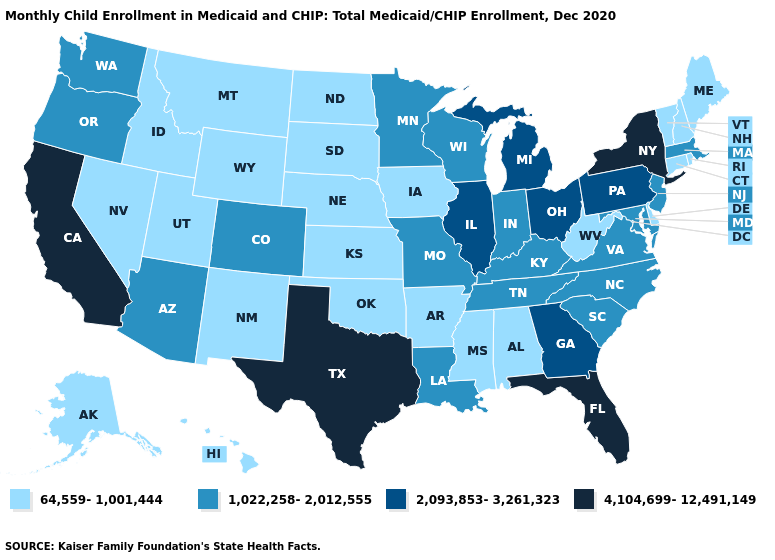What is the value of Oklahoma?
Answer briefly. 64,559-1,001,444. Which states hav the highest value in the Northeast?
Short answer required. New York. What is the value of Connecticut?
Give a very brief answer. 64,559-1,001,444. Name the states that have a value in the range 1,022,258-2,012,555?
Be succinct. Arizona, Colorado, Indiana, Kentucky, Louisiana, Maryland, Massachusetts, Minnesota, Missouri, New Jersey, North Carolina, Oregon, South Carolina, Tennessee, Virginia, Washington, Wisconsin. What is the value of Tennessee?
Keep it brief. 1,022,258-2,012,555. Name the states that have a value in the range 64,559-1,001,444?
Be succinct. Alabama, Alaska, Arkansas, Connecticut, Delaware, Hawaii, Idaho, Iowa, Kansas, Maine, Mississippi, Montana, Nebraska, Nevada, New Hampshire, New Mexico, North Dakota, Oklahoma, Rhode Island, South Dakota, Utah, Vermont, West Virginia, Wyoming. Does Florida have a lower value than Louisiana?
Short answer required. No. Does New Jersey have the highest value in the Northeast?
Write a very short answer. No. Does New York have the highest value in the Northeast?
Short answer required. Yes. Does West Virginia have a higher value than Hawaii?
Write a very short answer. No. Name the states that have a value in the range 1,022,258-2,012,555?
Concise answer only. Arizona, Colorado, Indiana, Kentucky, Louisiana, Maryland, Massachusetts, Minnesota, Missouri, New Jersey, North Carolina, Oregon, South Carolina, Tennessee, Virginia, Washington, Wisconsin. Name the states that have a value in the range 1,022,258-2,012,555?
Concise answer only. Arizona, Colorado, Indiana, Kentucky, Louisiana, Maryland, Massachusetts, Minnesota, Missouri, New Jersey, North Carolina, Oregon, South Carolina, Tennessee, Virginia, Washington, Wisconsin. What is the value of Vermont?
Short answer required. 64,559-1,001,444. Which states have the lowest value in the Northeast?
Be succinct. Connecticut, Maine, New Hampshire, Rhode Island, Vermont. Does Texas have the same value as Arizona?
Be succinct. No. 